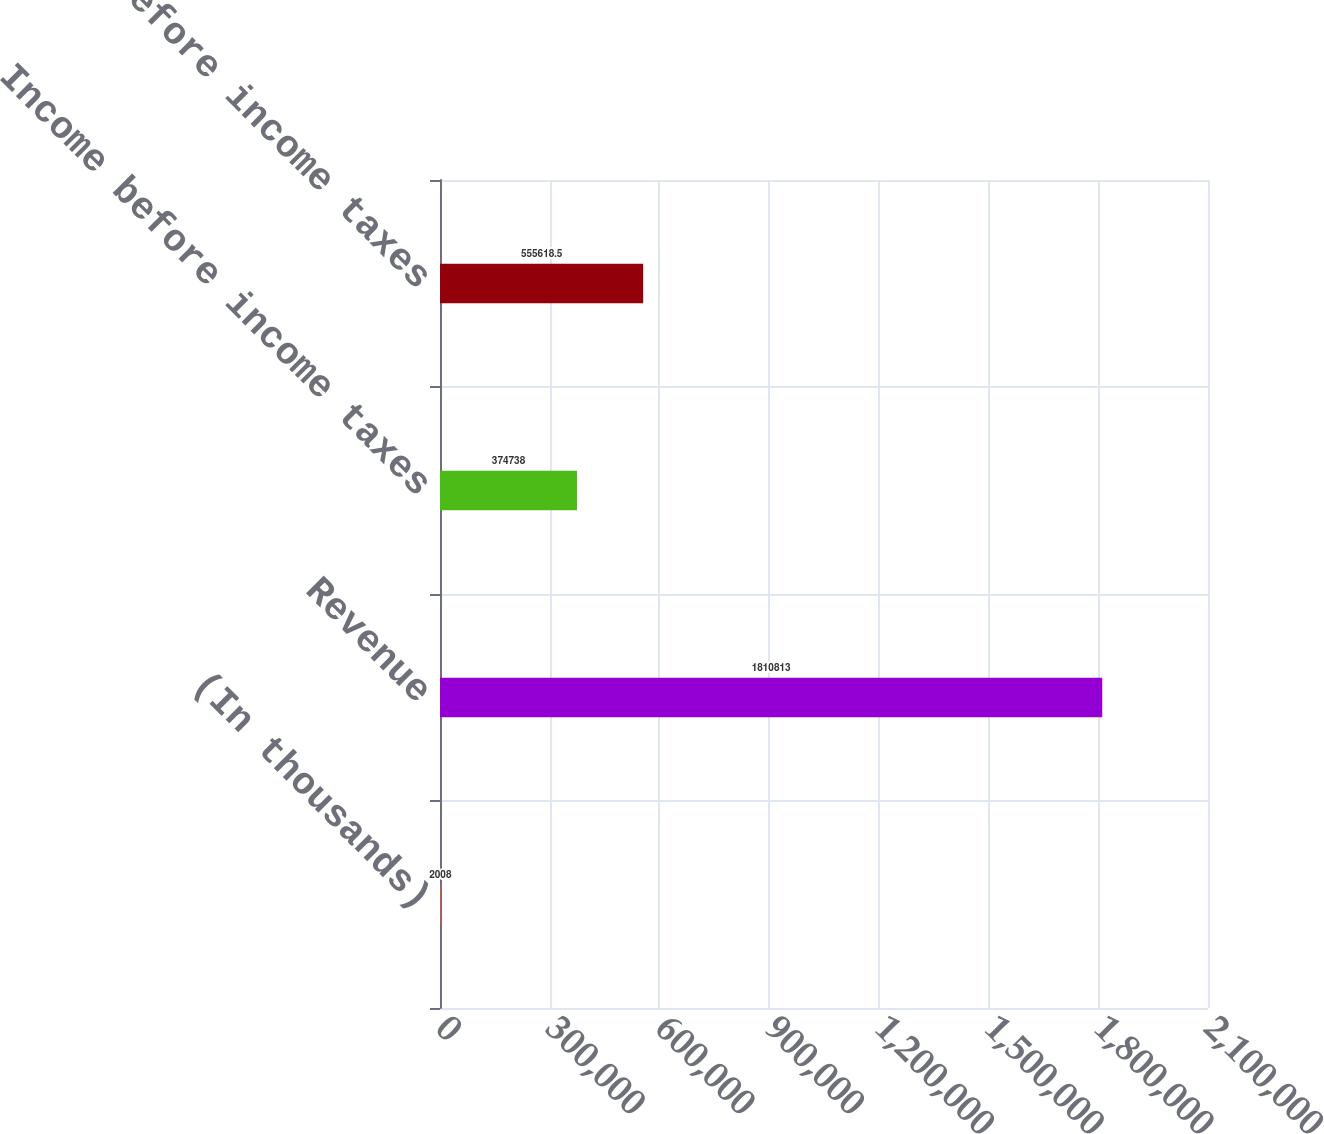Convert chart to OTSL. <chart><loc_0><loc_0><loc_500><loc_500><bar_chart><fcel>(In thousands)<fcel>Revenue<fcel>Income before income taxes<fcel>Loss before income taxes<nl><fcel>2008<fcel>1.81081e+06<fcel>374738<fcel>555618<nl></chart> 